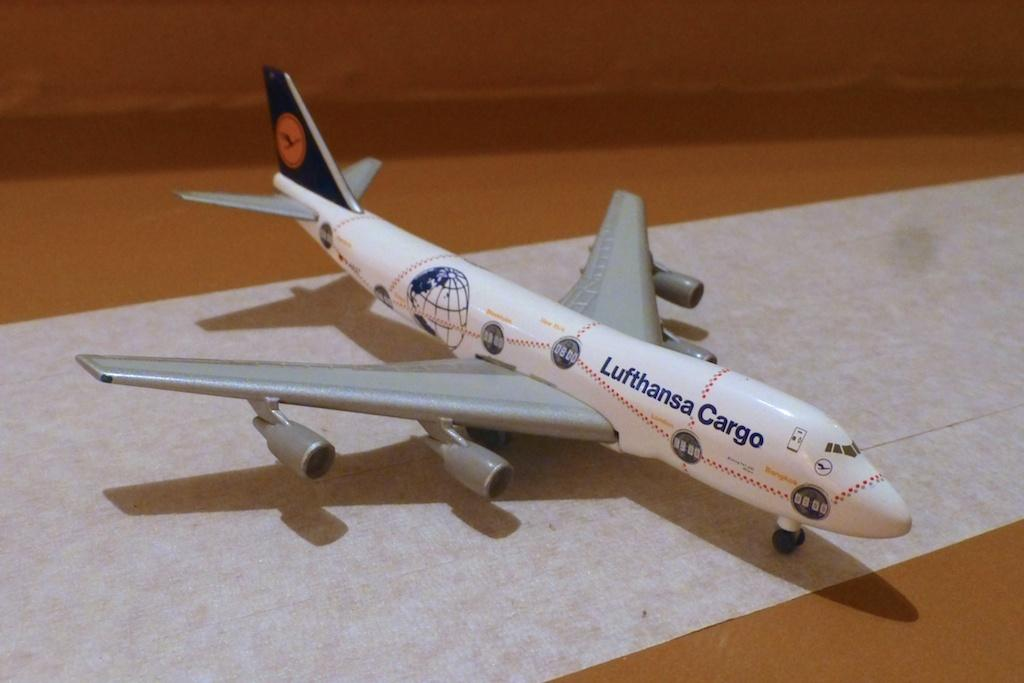<image>
Present a compact description of the photo's key features. The toy airplane has the word "Lufthansa Cargo" placed in the middle of it. 